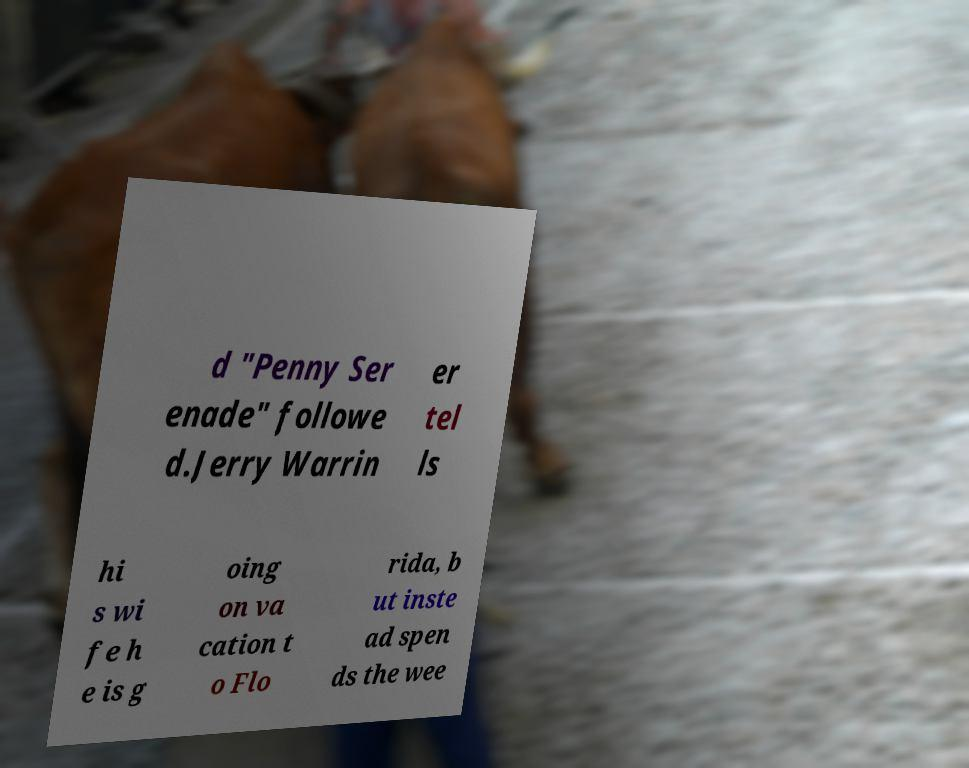Can you accurately transcribe the text from the provided image for me? d "Penny Ser enade" followe d.Jerry Warrin er tel ls hi s wi fe h e is g oing on va cation t o Flo rida, b ut inste ad spen ds the wee 